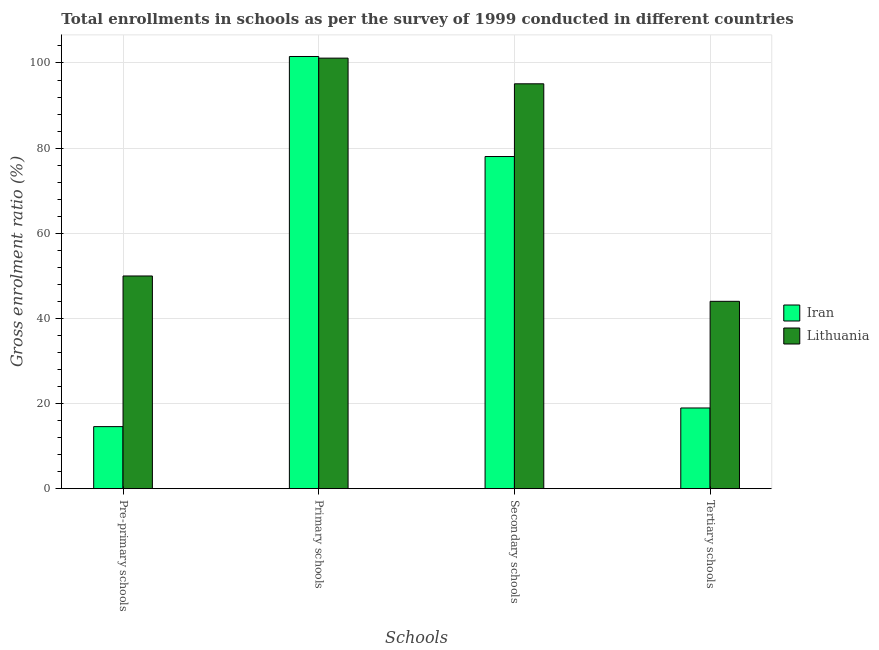Are the number of bars per tick equal to the number of legend labels?
Make the answer very short. Yes. How many bars are there on the 2nd tick from the left?
Your answer should be compact. 2. What is the label of the 3rd group of bars from the left?
Your response must be concise. Secondary schools. What is the gross enrolment ratio in secondary schools in Iran?
Provide a short and direct response. 78.03. Across all countries, what is the maximum gross enrolment ratio in tertiary schools?
Give a very brief answer. 44.01. Across all countries, what is the minimum gross enrolment ratio in primary schools?
Offer a very short reply. 101.14. In which country was the gross enrolment ratio in pre-primary schools maximum?
Make the answer very short. Lithuania. In which country was the gross enrolment ratio in secondary schools minimum?
Give a very brief answer. Iran. What is the total gross enrolment ratio in primary schools in the graph?
Give a very brief answer. 202.67. What is the difference between the gross enrolment ratio in pre-primary schools in Iran and that in Lithuania?
Your answer should be very brief. -35.39. What is the difference between the gross enrolment ratio in tertiary schools in Lithuania and the gross enrolment ratio in primary schools in Iran?
Your answer should be compact. -57.52. What is the average gross enrolment ratio in primary schools per country?
Your response must be concise. 101.33. What is the difference between the gross enrolment ratio in primary schools and gross enrolment ratio in tertiary schools in Lithuania?
Provide a short and direct response. 57.13. In how many countries, is the gross enrolment ratio in pre-primary schools greater than 92 %?
Offer a terse response. 0. What is the ratio of the gross enrolment ratio in secondary schools in Lithuania to that in Iran?
Provide a succinct answer. 1.22. Is the gross enrolment ratio in primary schools in Iran less than that in Lithuania?
Provide a short and direct response. No. What is the difference between the highest and the second highest gross enrolment ratio in tertiary schools?
Make the answer very short. 25.06. What is the difference between the highest and the lowest gross enrolment ratio in tertiary schools?
Your response must be concise. 25.06. In how many countries, is the gross enrolment ratio in tertiary schools greater than the average gross enrolment ratio in tertiary schools taken over all countries?
Keep it short and to the point. 1. What does the 1st bar from the left in Pre-primary schools represents?
Your answer should be compact. Iran. What does the 2nd bar from the right in Primary schools represents?
Ensure brevity in your answer.  Iran. Is it the case that in every country, the sum of the gross enrolment ratio in pre-primary schools and gross enrolment ratio in primary schools is greater than the gross enrolment ratio in secondary schools?
Provide a short and direct response. Yes. Are all the bars in the graph horizontal?
Your answer should be very brief. No. What is the difference between two consecutive major ticks on the Y-axis?
Ensure brevity in your answer.  20. Does the graph contain grids?
Offer a very short reply. Yes. How are the legend labels stacked?
Give a very brief answer. Vertical. What is the title of the graph?
Provide a succinct answer. Total enrollments in schools as per the survey of 1999 conducted in different countries. What is the label or title of the X-axis?
Your answer should be very brief. Schools. What is the Gross enrolment ratio (%) of Iran in Pre-primary schools?
Your response must be concise. 14.58. What is the Gross enrolment ratio (%) in Lithuania in Pre-primary schools?
Your answer should be compact. 49.97. What is the Gross enrolment ratio (%) in Iran in Primary schools?
Your answer should be compact. 101.53. What is the Gross enrolment ratio (%) of Lithuania in Primary schools?
Provide a succinct answer. 101.14. What is the Gross enrolment ratio (%) of Iran in Secondary schools?
Give a very brief answer. 78.03. What is the Gross enrolment ratio (%) in Lithuania in Secondary schools?
Ensure brevity in your answer.  95.11. What is the Gross enrolment ratio (%) in Iran in Tertiary schools?
Keep it short and to the point. 18.96. What is the Gross enrolment ratio (%) of Lithuania in Tertiary schools?
Keep it short and to the point. 44.01. Across all Schools, what is the maximum Gross enrolment ratio (%) in Iran?
Offer a terse response. 101.53. Across all Schools, what is the maximum Gross enrolment ratio (%) in Lithuania?
Offer a terse response. 101.14. Across all Schools, what is the minimum Gross enrolment ratio (%) in Iran?
Your answer should be very brief. 14.58. Across all Schools, what is the minimum Gross enrolment ratio (%) of Lithuania?
Your answer should be compact. 44.01. What is the total Gross enrolment ratio (%) in Iran in the graph?
Your response must be concise. 213.09. What is the total Gross enrolment ratio (%) in Lithuania in the graph?
Keep it short and to the point. 290.23. What is the difference between the Gross enrolment ratio (%) in Iran in Pre-primary schools and that in Primary schools?
Offer a terse response. -86.95. What is the difference between the Gross enrolment ratio (%) of Lithuania in Pre-primary schools and that in Primary schools?
Provide a succinct answer. -51.17. What is the difference between the Gross enrolment ratio (%) of Iran in Pre-primary schools and that in Secondary schools?
Your response must be concise. -63.45. What is the difference between the Gross enrolment ratio (%) of Lithuania in Pre-primary schools and that in Secondary schools?
Keep it short and to the point. -45.14. What is the difference between the Gross enrolment ratio (%) of Iran in Pre-primary schools and that in Tertiary schools?
Keep it short and to the point. -4.38. What is the difference between the Gross enrolment ratio (%) in Lithuania in Pre-primary schools and that in Tertiary schools?
Ensure brevity in your answer.  5.95. What is the difference between the Gross enrolment ratio (%) in Iran in Primary schools and that in Secondary schools?
Offer a very short reply. 23.5. What is the difference between the Gross enrolment ratio (%) in Lithuania in Primary schools and that in Secondary schools?
Your answer should be very brief. 6.03. What is the difference between the Gross enrolment ratio (%) of Iran in Primary schools and that in Tertiary schools?
Keep it short and to the point. 82.57. What is the difference between the Gross enrolment ratio (%) in Lithuania in Primary schools and that in Tertiary schools?
Ensure brevity in your answer.  57.13. What is the difference between the Gross enrolment ratio (%) in Iran in Secondary schools and that in Tertiary schools?
Your answer should be very brief. 59.07. What is the difference between the Gross enrolment ratio (%) in Lithuania in Secondary schools and that in Tertiary schools?
Offer a very short reply. 51.1. What is the difference between the Gross enrolment ratio (%) of Iran in Pre-primary schools and the Gross enrolment ratio (%) of Lithuania in Primary schools?
Ensure brevity in your answer.  -86.56. What is the difference between the Gross enrolment ratio (%) in Iran in Pre-primary schools and the Gross enrolment ratio (%) in Lithuania in Secondary schools?
Give a very brief answer. -80.53. What is the difference between the Gross enrolment ratio (%) in Iran in Pre-primary schools and the Gross enrolment ratio (%) in Lithuania in Tertiary schools?
Make the answer very short. -29.44. What is the difference between the Gross enrolment ratio (%) of Iran in Primary schools and the Gross enrolment ratio (%) of Lithuania in Secondary schools?
Your answer should be very brief. 6.42. What is the difference between the Gross enrolment ratio (%) of Iran in Primary schools and the Gross enrolment ratio (%) of Lithuania in Tertiary schools?
Offer a terse response. 57.52. What is the difference between the Gross enrolment ratio (%) in Iran in Secondary schools and the Gross enrolment ratio (%) in Lithuania in Tertiary schools?
Offer a terse response. 34.02. What is the average Gross enrolment ratio (%) of Iran per Schools?
Offer a terse response. 53.27. What is the average Gross enrolment ratio (%) in Lithuania per Schools?
Provide a succinct answer. 72.56. What is the difference between the Gross enrolment ratio (%) of Iran and Gross enrolment ratio (%) of Lithuania in Pre-primary schools?
Your answer should be very brief. -35.39. What is the difference between the Gross enrolment ratio (%) in Iran and Gross enrolment ratio (%) in Lithuania in Primary schools?
Provide a succinct answer. 0.39. What is the difference between the Gross enrolment ratio (%) of Iran and Gross enrolment ratio (%) of Lithuania in Secondary schools?
Your answer should be compact. -17.08. What is the difference between the Gross enrolment ratio (%) of Iran and Gross enrolment ratio (%) of Lithuania in Tertiary schools?
Provide a succinct answer. -25.06. What is the ratio of the Gross enrolment ratio (%) in Iran in Pre-primary schools to that in Primary schools?
Provide a succinct answer. 0.14. What is the ratio of the Gross enrolment ratio (%) in Lithuania in Pre-primary schools to that in Primary schools?
Offer a terse response. 0.49. What is the ratio of the Gross enrolment ratio (%) in Iran in Pre-primary schools to that in Secondary schools?
Your response must be concise. 0.19. What is the ratio of the Gross enrolment ratio (%) in Lithuania in Pre-primary schools to that in Secondary schools?
Provide a short and direct response. 0.53. What is the ratio of the Gross enrolment ratio (%) of Iran in Pre-primary schools to that in Tertiary schools?
Keep it short and to the point. 0.77. What is the ratio of the Gross enrolment ratio (%) of Lithuania in Pre-primary schools to that in Tertiary schools?
Your answer should be compact. 1.14. What is the ratio of the Gross enrolment ratio (%) of Iran in Primary schools to that in Secondary schools?
Your response must be concise. 1.3. What is the ratio of the Gross enrolment ratio (%) in Lithuania in Primary schools to that in Secondary schools?
Offer a terse response. 1.06. What is the ratio of the Gross enrolment ratio (%) of Iran in Primary schools to that in Tertiary schools?
Provide a succinct answer. 5.36. What is the ratio of the Gross enrolment ratio (%) in Lithuania in Primary schools to that in Tertiary schools?
Your response must be concise. 2.3. What is the ratio of the Gross enrolment ratio (%) of Iran in Secondary schools to that in Tertiary schools?
Offer a very short reply. 4.12. What is the ratio of the Gross enrolment ratio (%) of Lithuania in Secondary schools to that in Tertiary schools?
Ensure brevity in your answer.  2.16. What is the difference between the highest and the second highest Gross enrolment ratio (%) of Iran?
Offer a terse response. 23.5. What is the difference between the highest and the second highest Gross enrolment ratio (%) of Lithuania?
Provide a short and direct response. 6.03. What is the difference between the highest and the lowest Gross enrolment ratio (%) of Iran?
Ensure brevity in your answer.  86.95. What is the difference between the highest and the lowest Gross enrolment ratio (%) of Lithuania?
Your answer should be very brief. 57.13. 